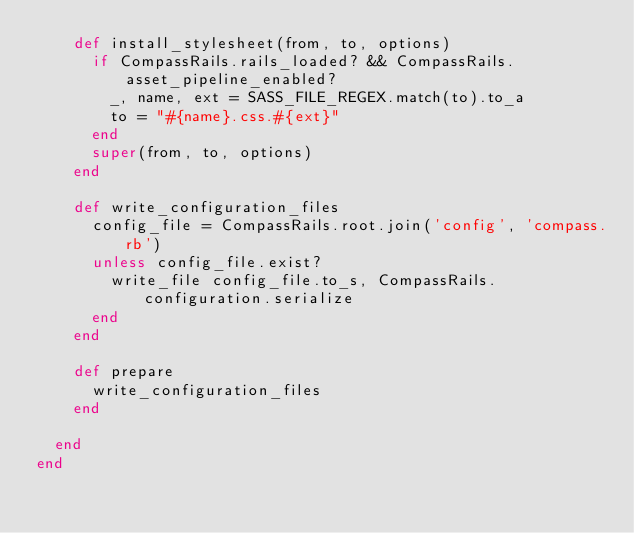Convert code to text. <code><loc_0><loc_0><loc_500><loc_500><_Ruby_>    def install_stylesheet(from, to, options)
      if CompassRails.rails_loaded? && CompassRails.asset_pipeline_enabled?
        _, name, ext = SASS_FILE_REGEX.match(to).to_a
        to = "#{name}.css.#{ext}"
      end
      super(from, to, options)
    end

    def write_configuration_files
      config_file = CompassRails.root.join('config', 'compass.rb')
      unless config_file.exist?
        write_file config_file.to_s, CompassRails.configuration.serialize
      end
    end

    def prepare
      write_configuration_files
    end

  end
end
</code> 